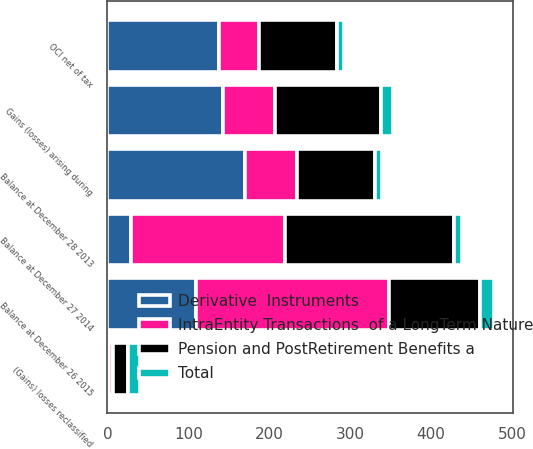<chart> <loc_0><loc_0><loc_500><loc_500><stacked_bar_chart><ecel><fcel>Balance at December 28 2013<fcel>Gains (losses) arising during<fcel>(Gains) losses reclassified<fcel>Balance at December 27 2014<fcel>OCI net of tax<fcel>Balance at December 26 2015<nl><fcel>Derivative  Instruments<fcel>170<fcel>143<fcel>2<fcel>29<fcel>138<fcel>109<nl><fcel>Pension and PostRetirement Benefits a<fcel>97<fcel>131<fcel>18<fcel>210<fcel>97<fcel>113<nl><fcel>Total<fcel>9<fcel>15<fcel>15<fcel>9<fcel>8<fcel>17<nl><fcel>IntraEntity Transactions  of a LongTerm Nature<fcel>64<fcel>64<fcel>5<fcel>190<fcel>49<fcel>239<nl></chart> 